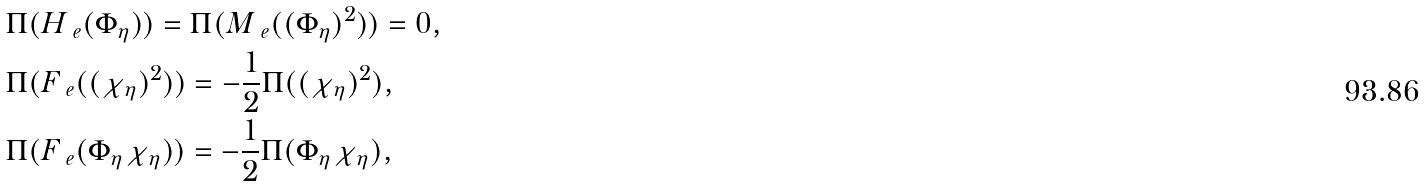Convert formula to latex. <formula><loc_0><loc_0><loc_500><loc_500>& \Pi ( H _ { \ e } ( \Phi _ { \eta } ) ) = \Pi ( M _ { \ e } ( ( \Phi _ { \eta } ) ^ { 2 } ) ) = 0 , \\ & \Pi ( F _ { \ e } ( ( \chi _ { \eta } ) ^ { 2 } ) ) = - \frac { 1 } { 2 } \Pi ( ( \chi _ { \eta } ) ^ { 2 } ) , \\ & \Pi ( F _ { \ e } ( \Phi _ { \eta } \chi _ { \eta } ) ) = - \frac { 1 } { 2 } \Pi ( \Phi _ { \eta } \chi _ { \eta } ) ,</formula> 